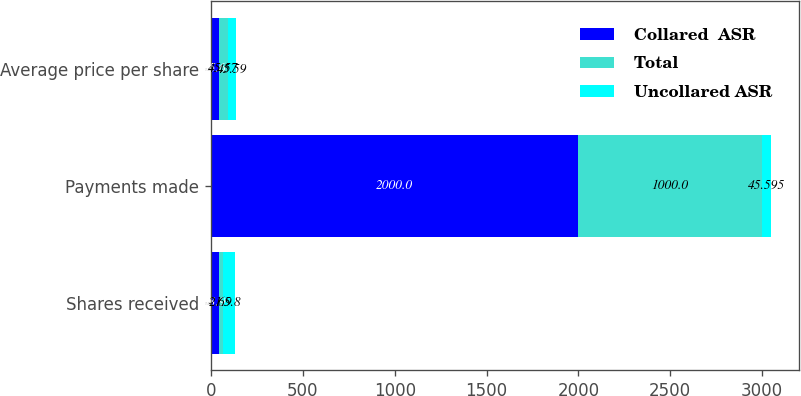Convert chart. <chart><loc_0><loc_0><loc_500><loc_500><stacked_bar_chart><ecel><fcel>Shares received<fcel>Payments made<fcel>Average price per share<nl><fcel>Collared  ASR<fcel>43.9<fcel>2000<fcel>45.6<nl><fcel>Total<fcel>21.9<fcel>1000<fcel>45.57<nl><fcel>Uncollared ASR<fcel>65.8<fcel>45.595<fcel>45.59<nl></chart> 